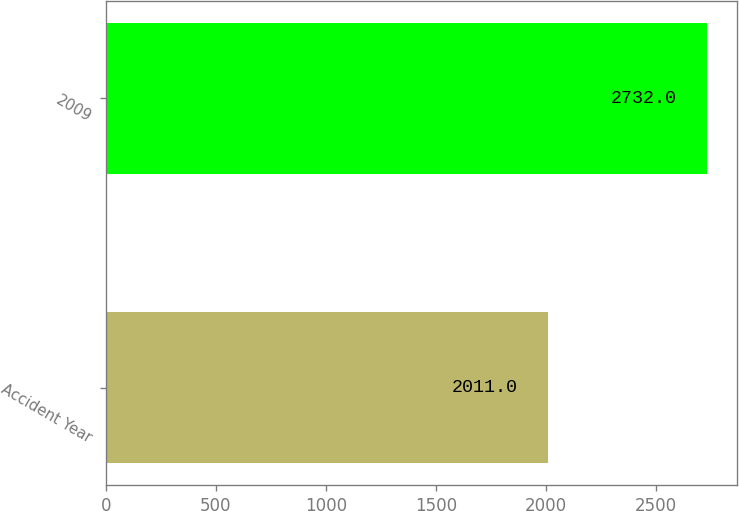Convert chart. <chart><loc_0><loc_0><loc_500><loc_500><bar_chart><fcel>Accident Year<fcel>2009<nl><fcel>2011<fcel>2732<nl></chart> 